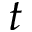Convert formula to latex. <formula><loc_0><loc_0><loc_500><loc_500>t</formula> 